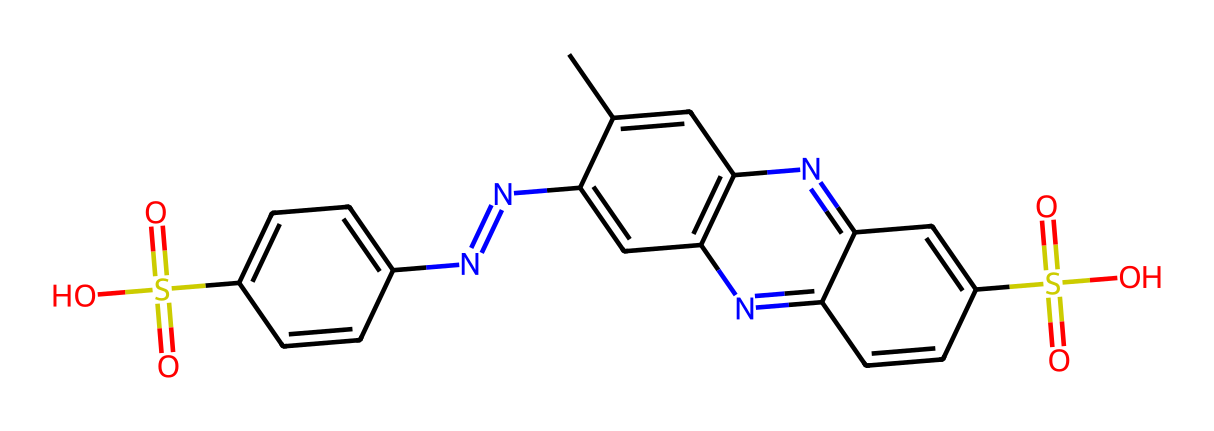How many nitrogen atoms are in this structure? By examining the SMILES representation, we can identify that there are four instances of the nitrogen atom (N). Counting each N in the representation confirms this count.
Answer: four What is the molecular formula of this compound? To determine the molecular formula, we count the individual atoms of each type present in the structure. The counts of carbon (C), hydrogen (H), nitrogen (N), sulfur (S), and oxygen (O) give us the formula C16H16N4O4S2.
Answer: C16H16N4O4S2 What types of functional groups are present in the dye? In the provided SMILES, we can identify sulfonic acid groups (-SO3H) indicated by the presence of the sulfur (S) and oxygen (O) atoms, alongside the nitrogen-containing rings which suggest basic aromatic functionalities.
Answer: sulfonic acid What type of dye is represented by this molecular structure? Analyzing the presence of nitrogen and the aromatic rings typically indicates that this is a type of azo dye, as indicated by the pattern in the molecular structure. Azo dyes are characterized by the presence of diazo (-N=N-) groups or similar structures.
Answer: azo dye How many aromatic rings are in this ink dye? The chemical structure indicates two distinct aromatic rings formed by carbon atoms and the alternating double bonds in the structure. Counting these gives us a total of two aromatic rings.
Answer: two What is the oxidation state of the sulfur atoms in this compound? In the given SMILES representation, the oxidation state of sulfur in a sulfonic acid typically is +6 due to its connection with three oxygens (two of which are connected with double bonds and one with a single bond).
Answer: +6 Which part of the chemical structure gives this dye its color properties? The presence of the conjugated double-bond system associated with the nitrogen-containing aromatic rings contributes to the dye's ability to absorb visible light, which is responsible for its color properties.
Answer: conjugated double-bond system 